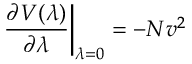Convert formula to latex. <formula><loc_0><loc_0><loc_500><loc_500>\frac { \partial V ( \lambda ) } { \partial \lambda } \right | _ { \lambda = 0 } = - N v ^ { 2 }</formula> 